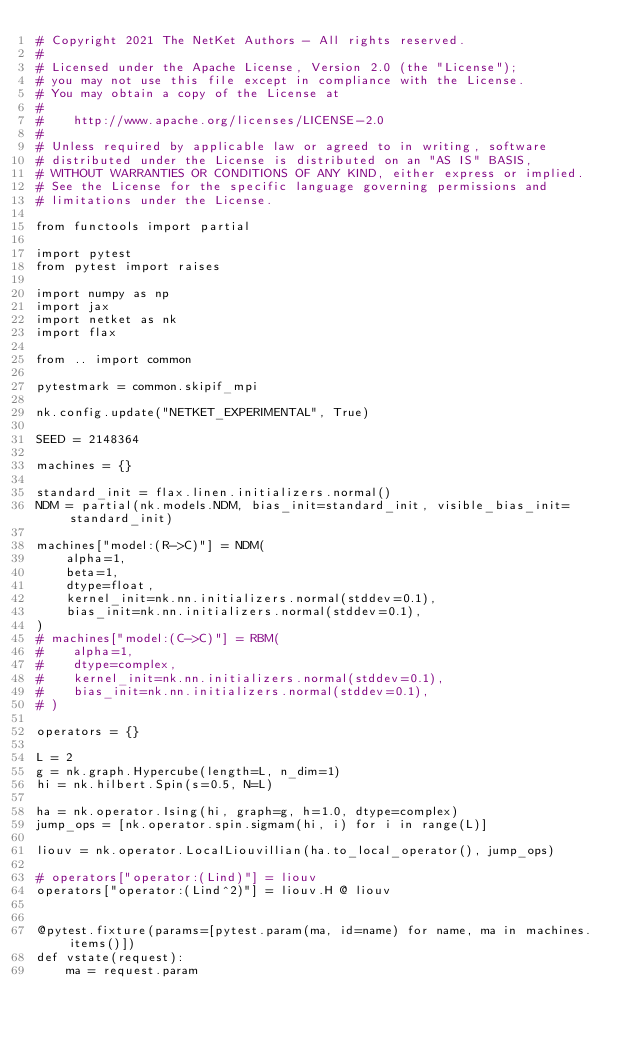<code> <loc_0><loc_0><loc_500><loc_500><_Python_># Copyright 2021 The NetKet Authors - All rights reserved.
#
# Licensed under the Apache License, Version 2.0 (the "License");
# you may not use this file except in compliance with the License.
# You may obtain a copy of the License at
#
#    http://www.apache.org/licenses/LICENSE-2.0
#
# Unless required by applicable law or agreed to in writing, software
# distributed under the License is distributed on an "AS IS" BASIS,
# WITHOUT WARRANTIES OR CONDITIONS OF ANY KIND, either express or implied.
# See the License for the specific language governing permissions and
# limitations under the License.

from functools import partial

import pytest
from pytest import raises

import numpy as np
import jax
import netket as nk
import flax

from .. import common

pytestmark = common.skipif_mpi

nk.config.update("NETKET_EXPERIMENTAL", True)

SEED = 2148364

machines = {}

standard_init = flax.linen.initializers.normal()
NDM = partial(nk.models.NDM, bias_init=standard_init, visible_bias_init=standard_init)

machines["model:(R->C)"] = NDM(
    alpha=1,
    beta=1,
    dtype=float,
    kernel_init=nk.nn.initializers.normal(stddev=0.1),
    bias_init=nk.nn.initializers.normal(stddev=0.1),
)
# machines["model:(C->C)"] = RBM(
#    alpha=1,
#    dtype=complex,
#    kernel_init=nk.nn.initializers.normal(stddev=0.1),
#    bias_init=nk.nn.initializers.normal(stddev=0.1),
# )

operators = {}

L = 2
g = nk.graph.Hypercube(length=L, n_dim=1)
hi = nk.hilbert.Spin(s=0.5, N=L)

ha = nk.operator.Ising(hi, graph=g, h=1.0, dtype=complex)
jump_ops = [nk.operator.spin.sigmam(hi, i) for i in range(L)]

liouv = nk.operator.LocalLiouvillian(ha.to_local_operator(), jump_ops)

# operators["operator:(Lind)"] = liouv
operators["operator:(Lind^2)"] = liouv.H @ liouv


@pytest.fixture(params=[pytest.param(ma, id=name) for name, ma in machines.items()])
def vstate(request):
    ma = request.param
</code> 